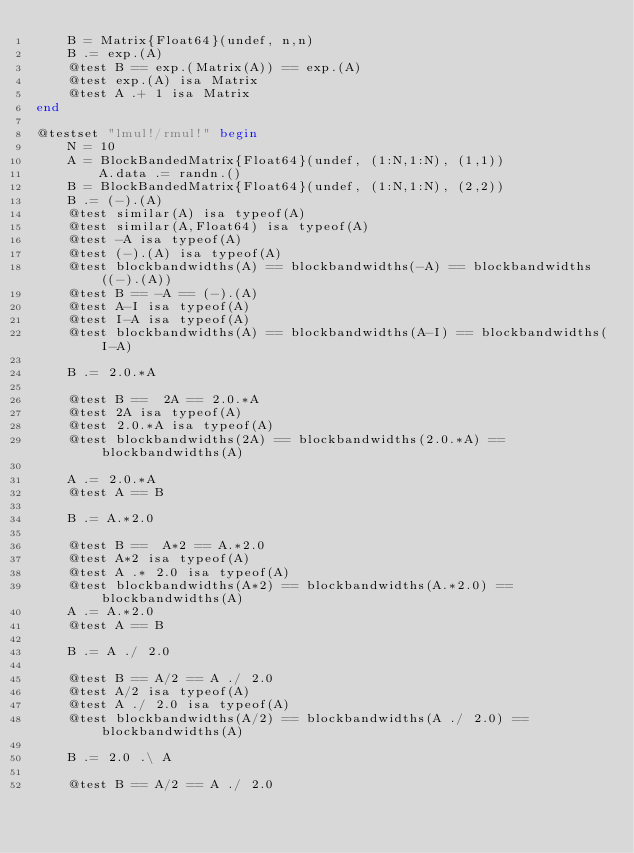Convert code to text. <code><loc_0><loc_0><loc_500><loc_500><_Julia_>    B = Matrix{Float64}(undef, n,n)
    B .= exp.(A)
    @test B == exp.(Matrix(A)) == exp.(A)
    @test exp.(A) isa Matrix
    @test A .+ 1 isa Matrix
end

@testset "lmul!/rmul!" begin
    N = 10
    A = BlockBandedMatrix{Float64}(undef, (1:N,1:N), (1,1))
        A.data .= randn.()
    B = BlockBandedMatrix{Float64}(undef, (1:N,1:N), (2,2))
    B .= (-).(A)
    @test similar(A) isa typeof(A)
    @test similar(A,Float64) isa typeof(A)
    @test -A isa typeof(A)
    @test (-).(A) isa typeof(A)
    @test blockbandwidths(A) == blockbandwidths(-A) == blockbandwidths((-).(A))
    @test B == -A == (-).(A)
    @test A-I isa typeof(A)
    @test I-A isa typeof(A)
    @test blockbandwidths(A) == blockbandwidths(A-I) == blockbandwidths(I-A)

    B .= 2.0.*A

    @test B ==  2A == 2.0.*A
    @test 2A isa typeof(A)
    @test 2.0.*A isa typeof(A)
    @test blockbandwidths(2A) == blockbandwidths(2.0.*A) == blockbandwidths(A)

    A .= 2.0.*A
    @test A == B

    B .= A.*2.0

    @test B ==  A*2 == A.*2.0
    @test A*2 isa typeof(A)
    @test A .* 2.0 isa typeof(A)
    @test blockbandwidths(A*2) == blockbandwidths(A.*2.0) == blockbandwidths(A)
    A .= A.*2.0
    @test A == B

    B .= A ./ 2.0

    @test B == A/2 == A ./ 2.0
    @test A/2 isa typeof(A)
    @test A ./ 2.0 isa typeof(A)
    @test blockbandwidths(A/2) == blockbandwidths(A ./ 2.0) == blockbandwidths(A)

    B .= 2.0 .\ A

    @test B == A/2 == A ./ 2.0</code> 